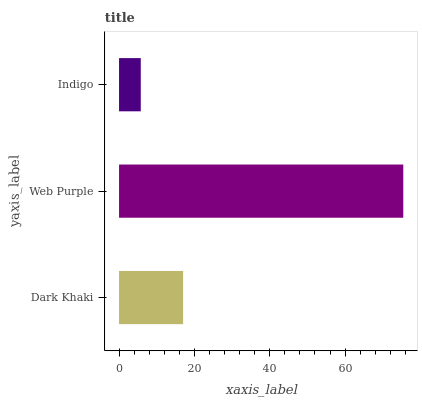Is Indigo the minimum?
Answer yes or no. Yes. Is Web Purple the maximum?
Answer yes or no. Yes. Is Web Purple the minimum?
Answer yes or no. No. Is Indigo the maximum?
Answer yes or no. No. Is Web Purple greater than Indigo?
Answer yes or no. Yes. Is Indigo less than Web Purple?
Answer yes or no. Yes. Is Indigo greater than Web Purple?
Answer yes or no. No. Is Web Purple less than Indigo?
Answer yes or no. No. Is Dark Khaki the high median?
Answer yes or no. Yes. Is Dark Khaki the low median?
Answer yes or no. Yes. Is Web Purple the high median?
Answer yes or no. No. Is Indigo the low median?
Answer yes or no. No. 